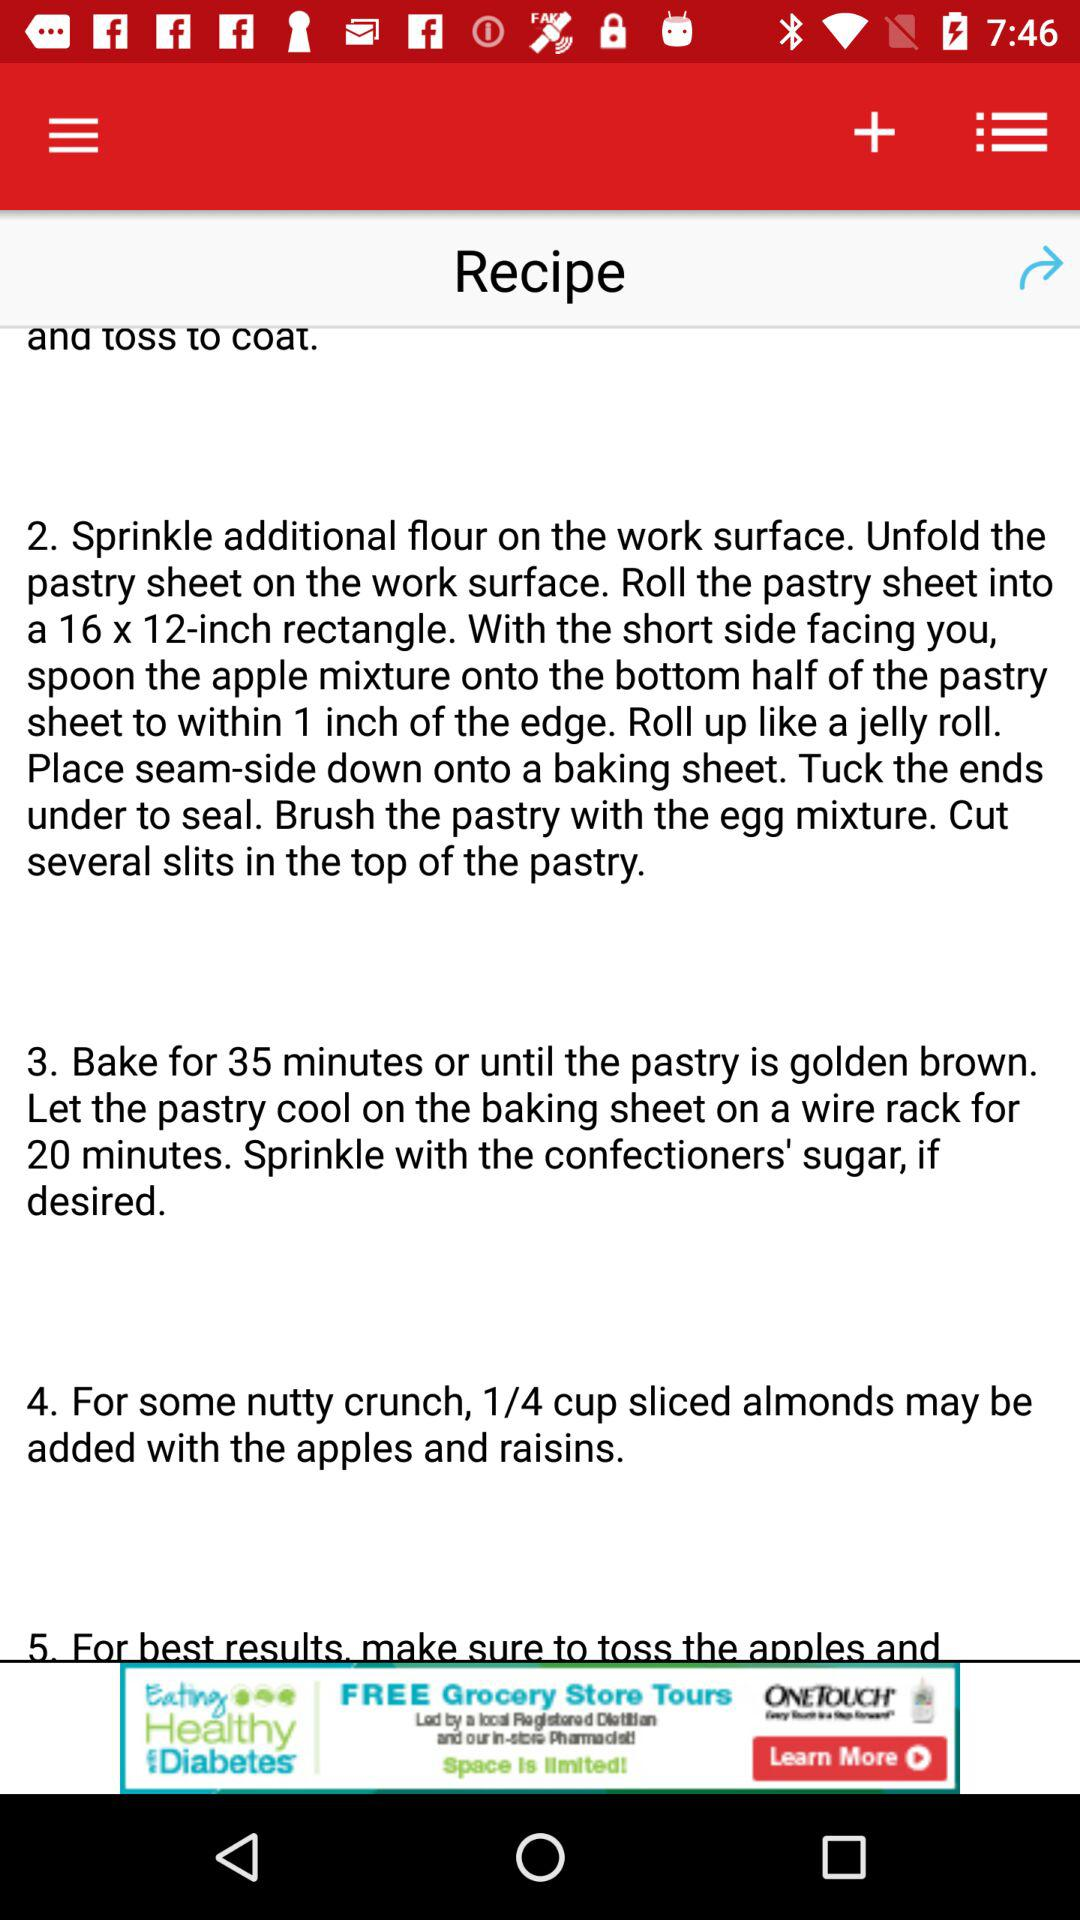How many steps does the recipe have?
Answer the question using a single word or phrase. 5 